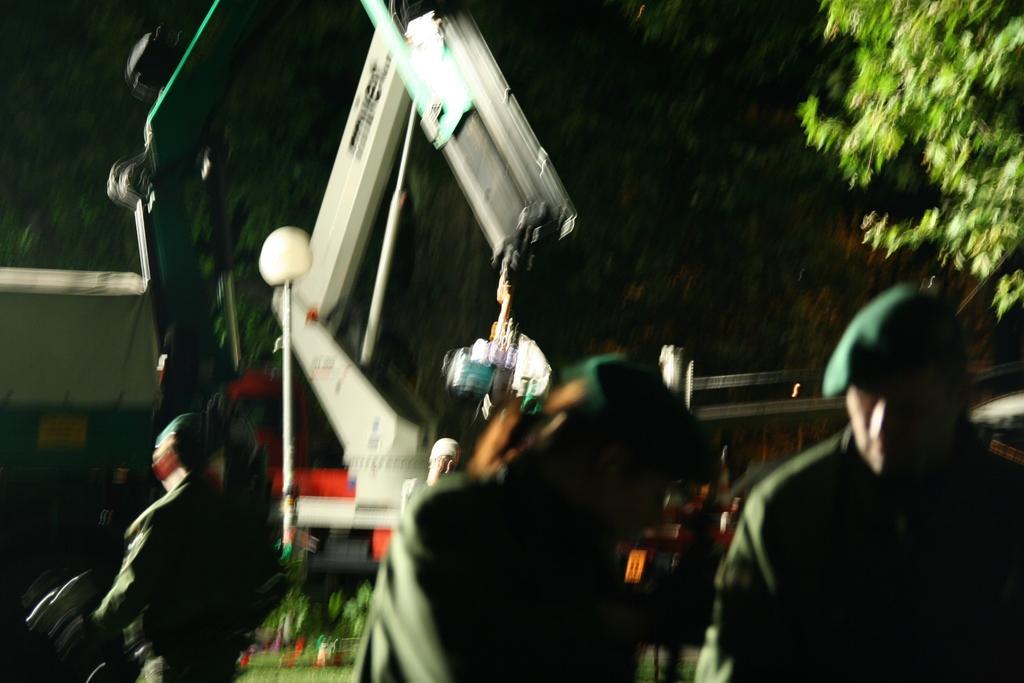How would you summarize this image in a sentence or two? In this picture I can observe some persons. In the middle of the picture there is a crane. On the right side I can observe tree. 